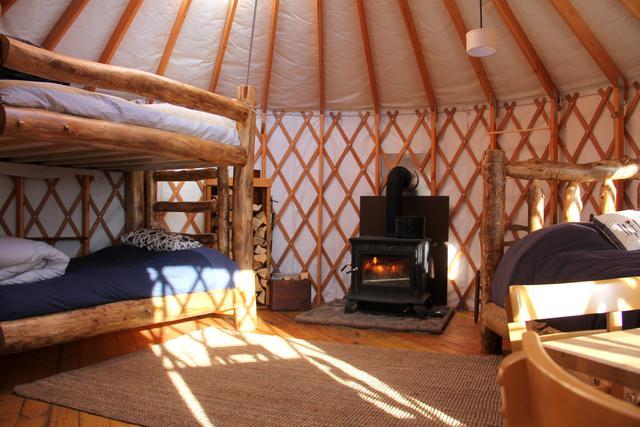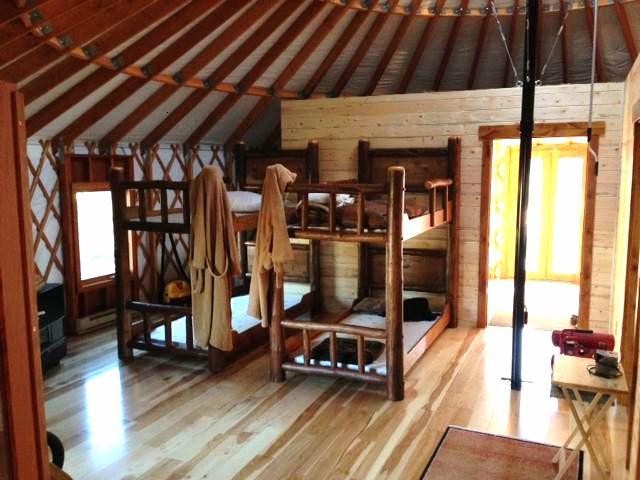The first image is the image on the left, the second image is the image on the right. Analyze the images presented: Is the assertion "An image shows a round structure surrounded by a round railed deck, and the structure has lattice-work showing in the windows." valid? Answer yes or no. No. The first image is the image on the left, the second image is the image on the right. Evaluate the accuracy of this statement regarding the images: "Each image shows the snowy winter exterior of a yurt, with decking of wooden posts and railings.". Is it true? Answer yes or no. No. 